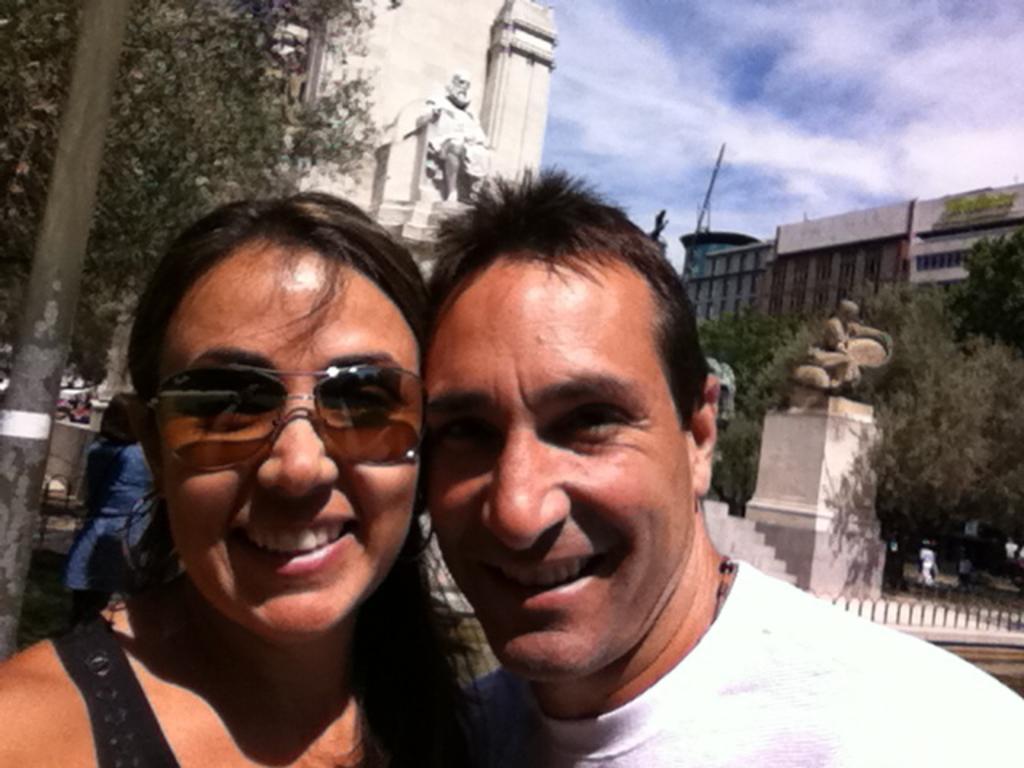Describe this image in one or two sentences. In this image, we can see a man and woman are seeing and smiling. Here a woman is wearing goggles. Background we can see buildings, statues, pole, trees, stairs, few people. Here there is a sky. 